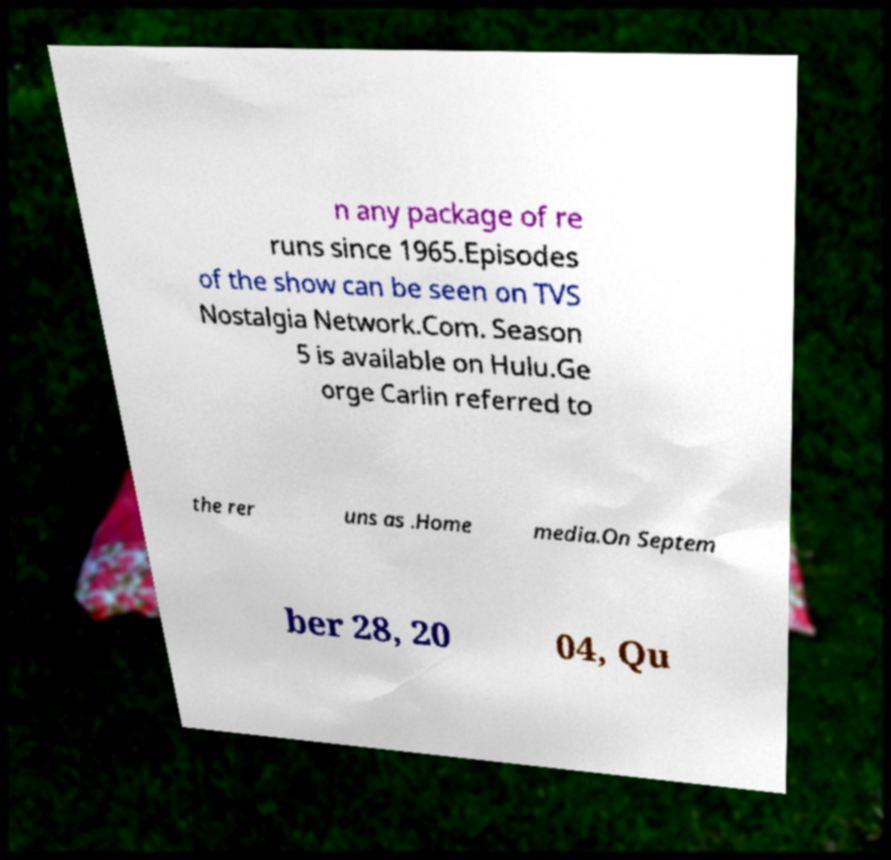I need the written content from this picture converted into text. Can you do that? n any package of re runs since 1965.Episodes of the show can be seen on TVS Nostalgia Network.Com. Season 5 is available on Hulu.Ge orge Carlin referred to the rer uns as .Home media.On Septem ber 28, 20 04, Qu 